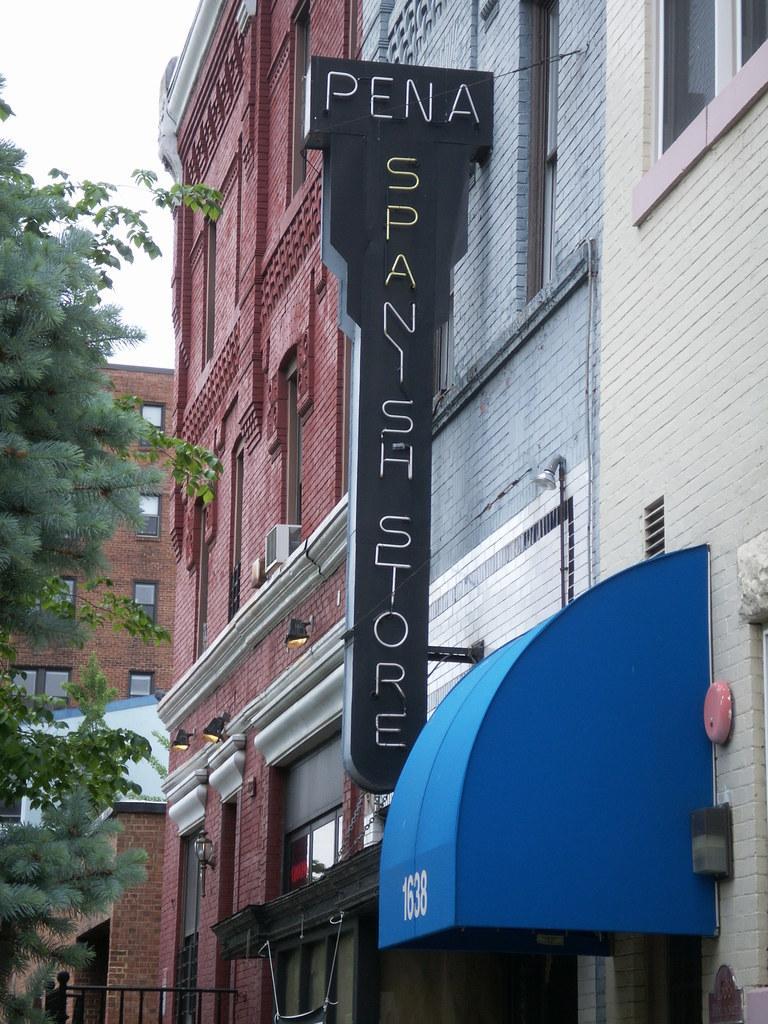In one or two sentences, can you explain what this image depicts? In this image we can see some buildings with windows. We can also see a signboard with some text on it, a fence, a roof, some lights, tree and the sky which looks cloudy. 